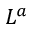<formula> <loc_0><loc_0><loc_500><loc_500>L ^ { a }</formula> 